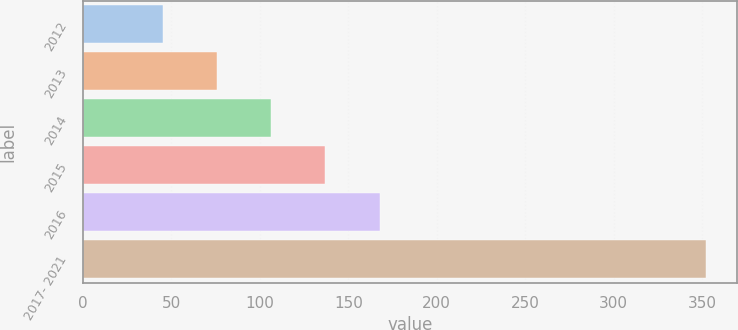Convert chart to OTSL. <chart><loc_0><loc_0><loc_500><loc_500><bar_chart><fcel>2012<fcel>2013<fcel>2014<fcel>2015<fcel>2016<fcel>2017- 2021<nl><fcel>45<fcel>75.7<fcel>106.4<fcel>137.1<fcel>167.8<fcel>352<nl></chart> 